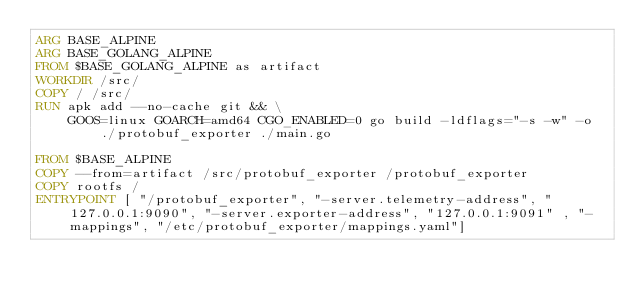Convert code to text. <code><loc_0><loc_0><loc_500><loc_500><_Dockerfile_>ARG BASE_ALPINE
ARG BASE_GOLANG_ALPINE
FROM $BASE_GOLANG_ALPINE as artifact
WORKDIR /src/
COPY / /src/
RUN apk add --no-cache git && \
    GOOS=linux GOARCH=amd64 CGO_ENABLED=0 go build -ldflags="-s -w" -o ./protobuf_exporter ./main.go

FROM $BASE_ALPINE
COPY --from=artifact /src/protobuf_exporter /protobuf_exporter
COPY rootfs /
ENTRYPOINT [ "/protobuf_exporter", "-server.telemetry-address", "127.0.0.1:9090", "-server.exporter-address", "127.0.0.1:9091" , "-mappings", "/etc/protobuf_exporter/mappings.yaml"]
</code> 